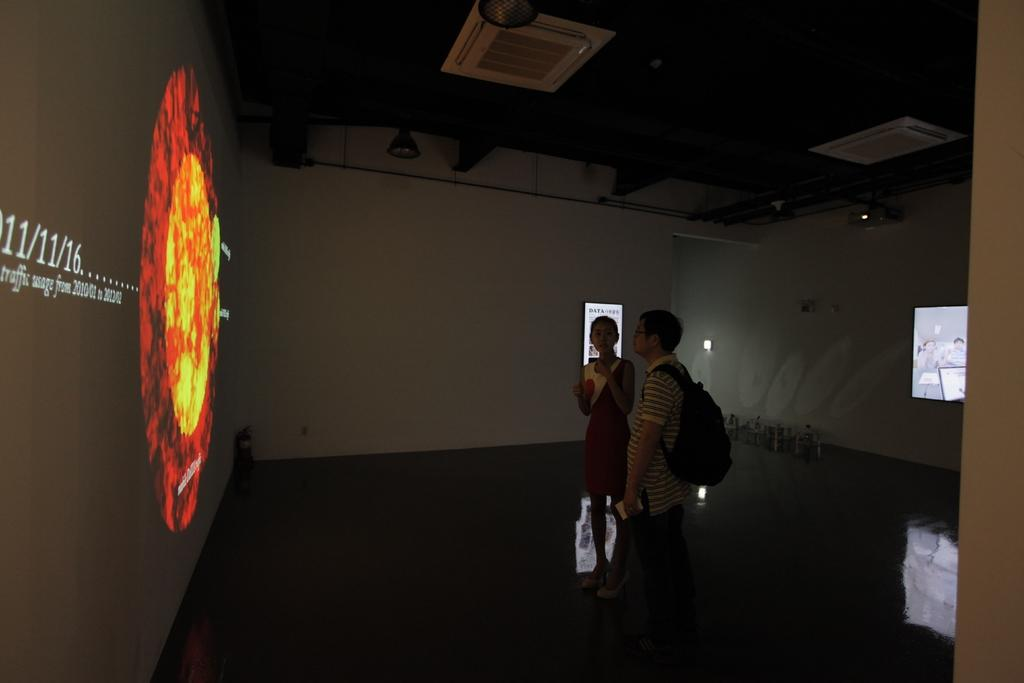Who are the people in the image? There is a man and a woman in the image. Where are the man and woman located in the image? The man and woman are in the center of the image. What can be seen on the walls in the image? There are screens on the walls in the image. What is on the roof in the image? There are lamps on the roof in the image. What type of honey can be seen dripping from the lamps on the roof in the image? There is no honey present in the image; the lamps on the roof are not associated with any honey. 